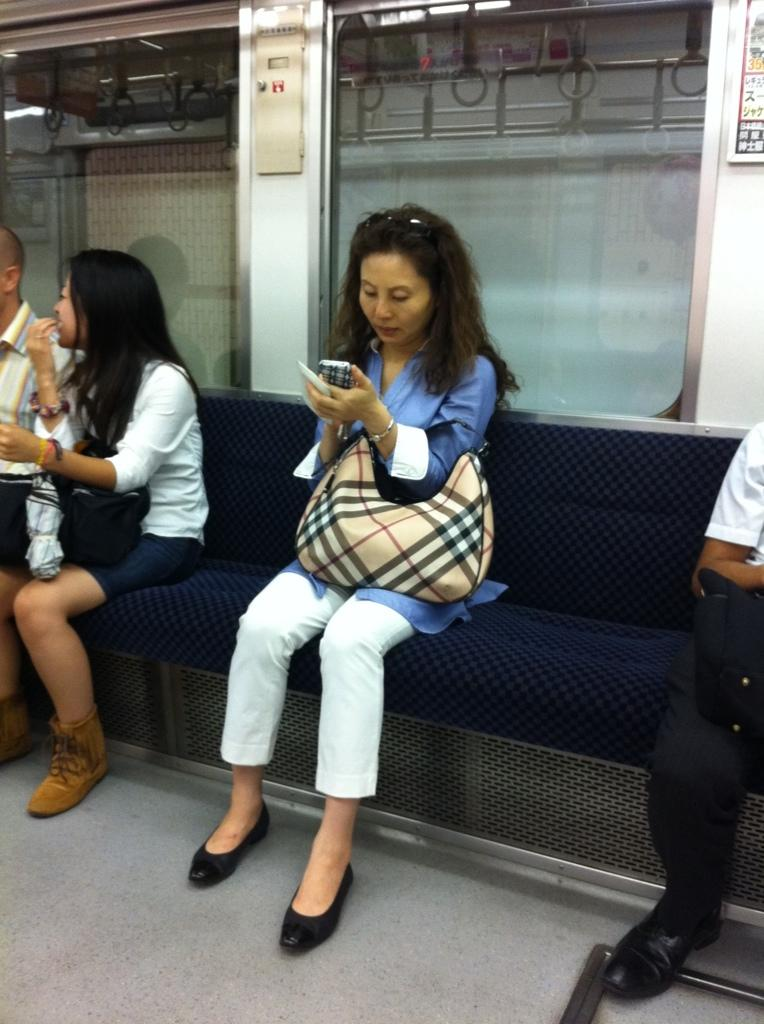What is the setting of the image? The image shows the inside of a vehicle. What can be seen inside the vehicle? There are people sitting on seats in the vehicle. What type of twig is being used as a footrest in the image? There is no twig present in the image, and no footrest is visible. 